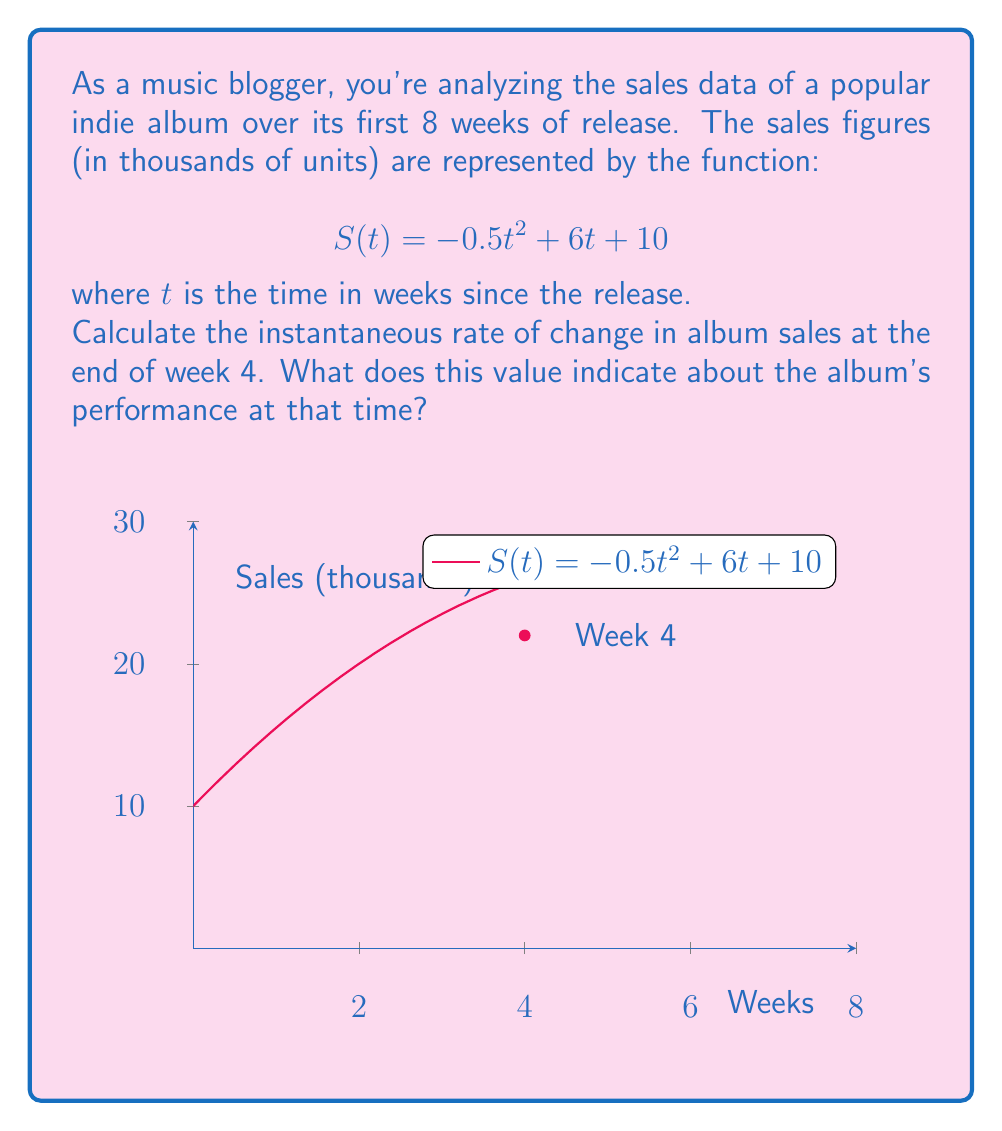What is the answer to this math problem? To find the instantaneous rate of change at week 4, we need to calculate the derivative of the function $S(t)$ and evaluate it at $t=4$. Here's the step-by-step process:

1) The given function is $S(t) = -0.5t^2 + 6t + 10$

2) To find the derivative, we apply the power rule and constant rule:
   $$S'(t) = -0.5 \cdot 2t + 6 + 0 = -t + 6$$

3) Now we evaluate $S'(t)$ at $t=4$:
   $$S'(4) = -4 + 6 = 2$$

4) Therefore, the instantaneous rate of change at week 4 is 2 thousand units per week.

5) Interpretation: This positive value indicates that at the end of week 4, the album sales were still increasing, but at a slower rate than initially. The sales are growing by 2,000 units per week at this point.

6) Note: Since the coefficient of $t^2$ is negative in the original function, we know that this is a concave down parabola, meaning the sales will eventually start decreasing. The turning point can be found by setting $S'(t) = 0$, which occurs at $t=6$ weeks.
Answer: 2 thousand units per week, indicating increasing but slowing sales 